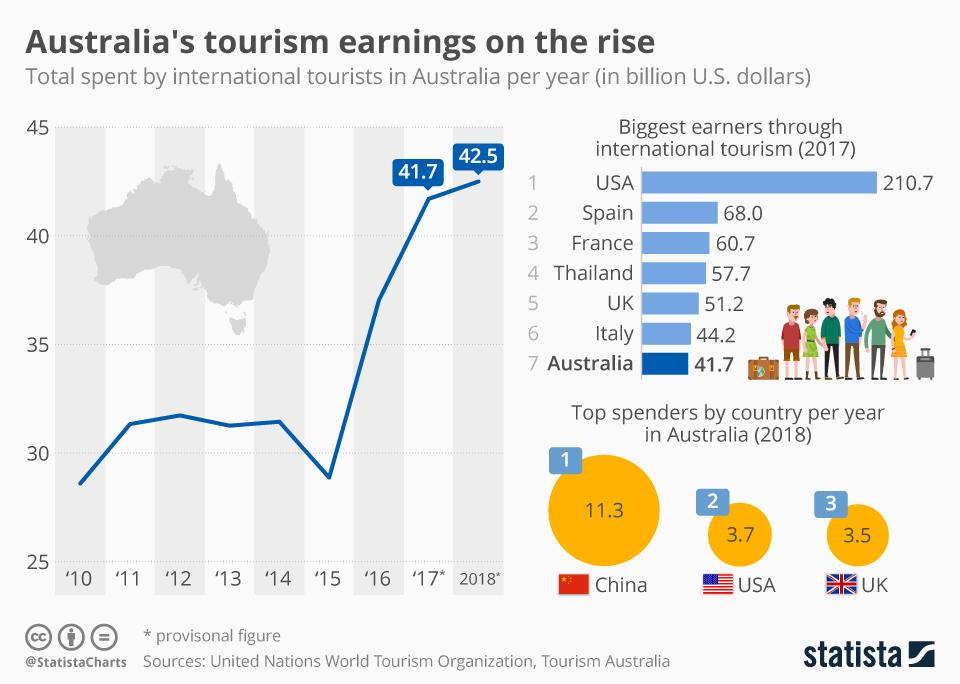List a handful of essential elements in this visual. In 2018, Australia earned the highest amount in tourism. In 2017, the United States was the country with the highest earnings through international tourism. Australia ranked third in spending among the countries that spent the most in the UK. 